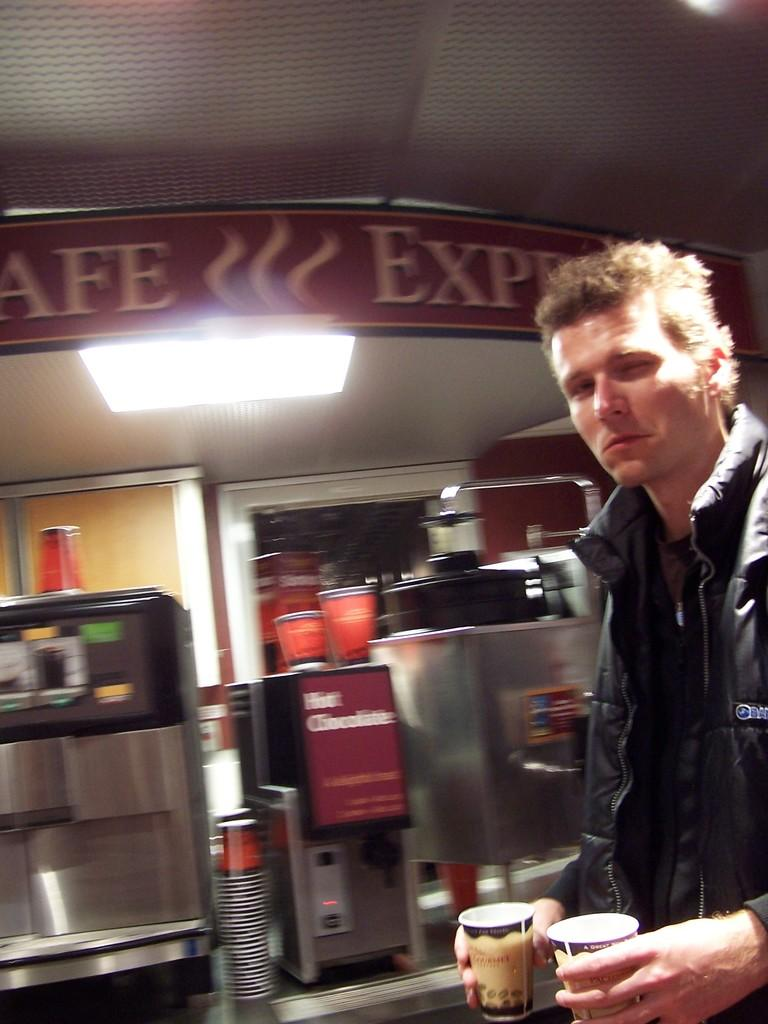<image>
Summarize the visual content of the image. Hot Chocolate sign on a coffee maker machine. 